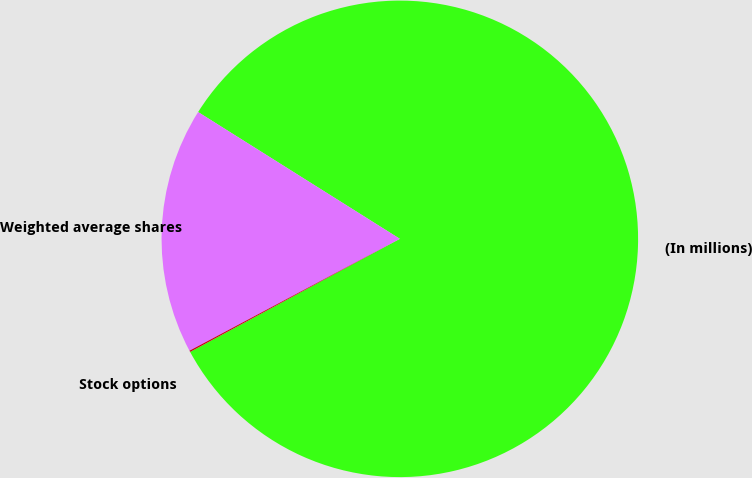Convert chart. <chart><loc_0><loc_0><loc_500><loc_500><pie_chart><fcel>(In millions)<fcel>Weighted average shares<fcel>Stock options<nl><fcel>83.2%<fcel>16.71%<fcel>0.09%<nl></chart> 